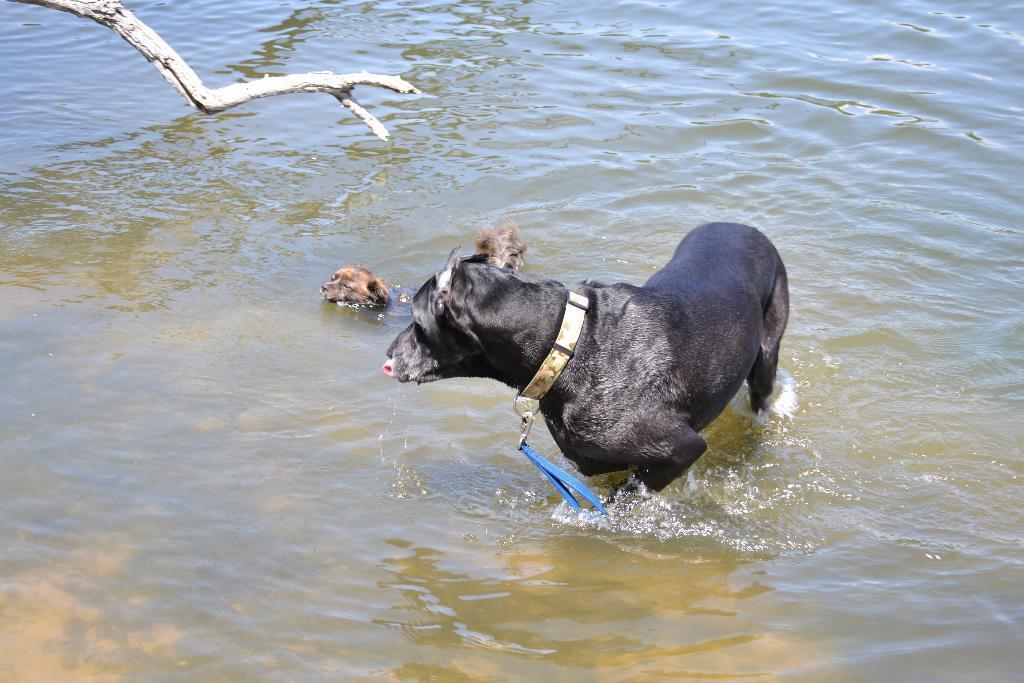Please provide a concise description of this image. In the center of the picture there are two dogs in the water. On the left there is a wooden trunk. 